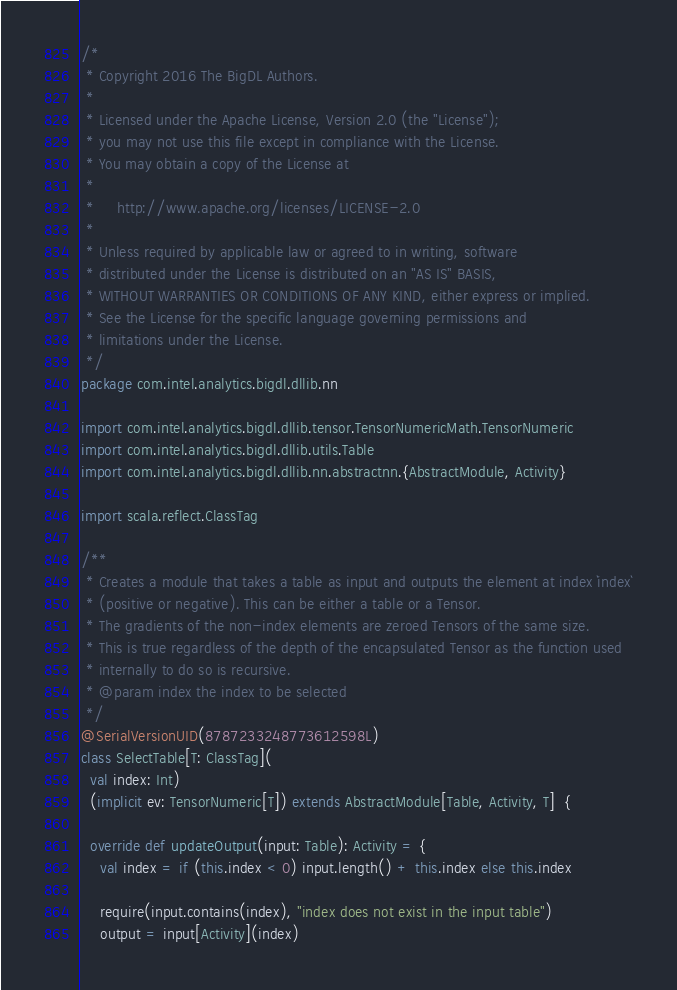<code> <loc_0><loc_0><loc_500><loc_500><_Scala_>/*
 * Copyright 2016 The BigDL Authors.
 *
 * Licensed under the Apache License, Version 2.0 (the "License");
 * you may not use this file except in compliance with the License.
 * You may obtain a copy of the License at
 *
 *     http://www.apache.org/licenses/LICENSE-2.0
 *
 * Unless required by applicable law or agreed to in writing, software
 * distributed under the License is distributed on an "AS IS" BASIS,
 * WITHOUT WARRANTIES OR CONDITIONS OF ANY KIND, either express or implied.
 * See the License for the specific language governing permissions and
 * limitations under the License.
 */
package com.intel.analytics.bigdl.dllib.nn

import com.intel.analytics.bigdl.dllib.tensor.TensorNumericMath.TensorNumeric
import com.intel.analytics.bigdl.dllib.utils.Table
import com.intel.analytics.bigdl.dllib.nn.abstractnn.{AbstractModule, Activity}

import scala.reflect.ClassTag

/**
 * Creates a module that takes a table as input and outputs the element at index `index`
 * (positive or negative). This can be either a table or a Tensor.
 * The gradients of the non-index elements are zeroed Tensors of the same size.
 * This is true regardless of the depth of the encapsulated Tensor as the function used
 * internally to do so is recursive.
 * @param index the index to be selected
 */
@SerialVersionUID(8787233248773612598L)
class SelectTable[T: ClassTag](
  val index: Int)
  (implicit ev: TensorNumeric[T]) extends AbstractModule[Table, Activity, T]  {

  override def updateOutput(input: Table): Activity = {
    val index = if (this.index < 0) input.length() + this.index else this.index

    require(input.contains(index), "index does not exist in the input table")
    output = input[Activity](index)
</code> 